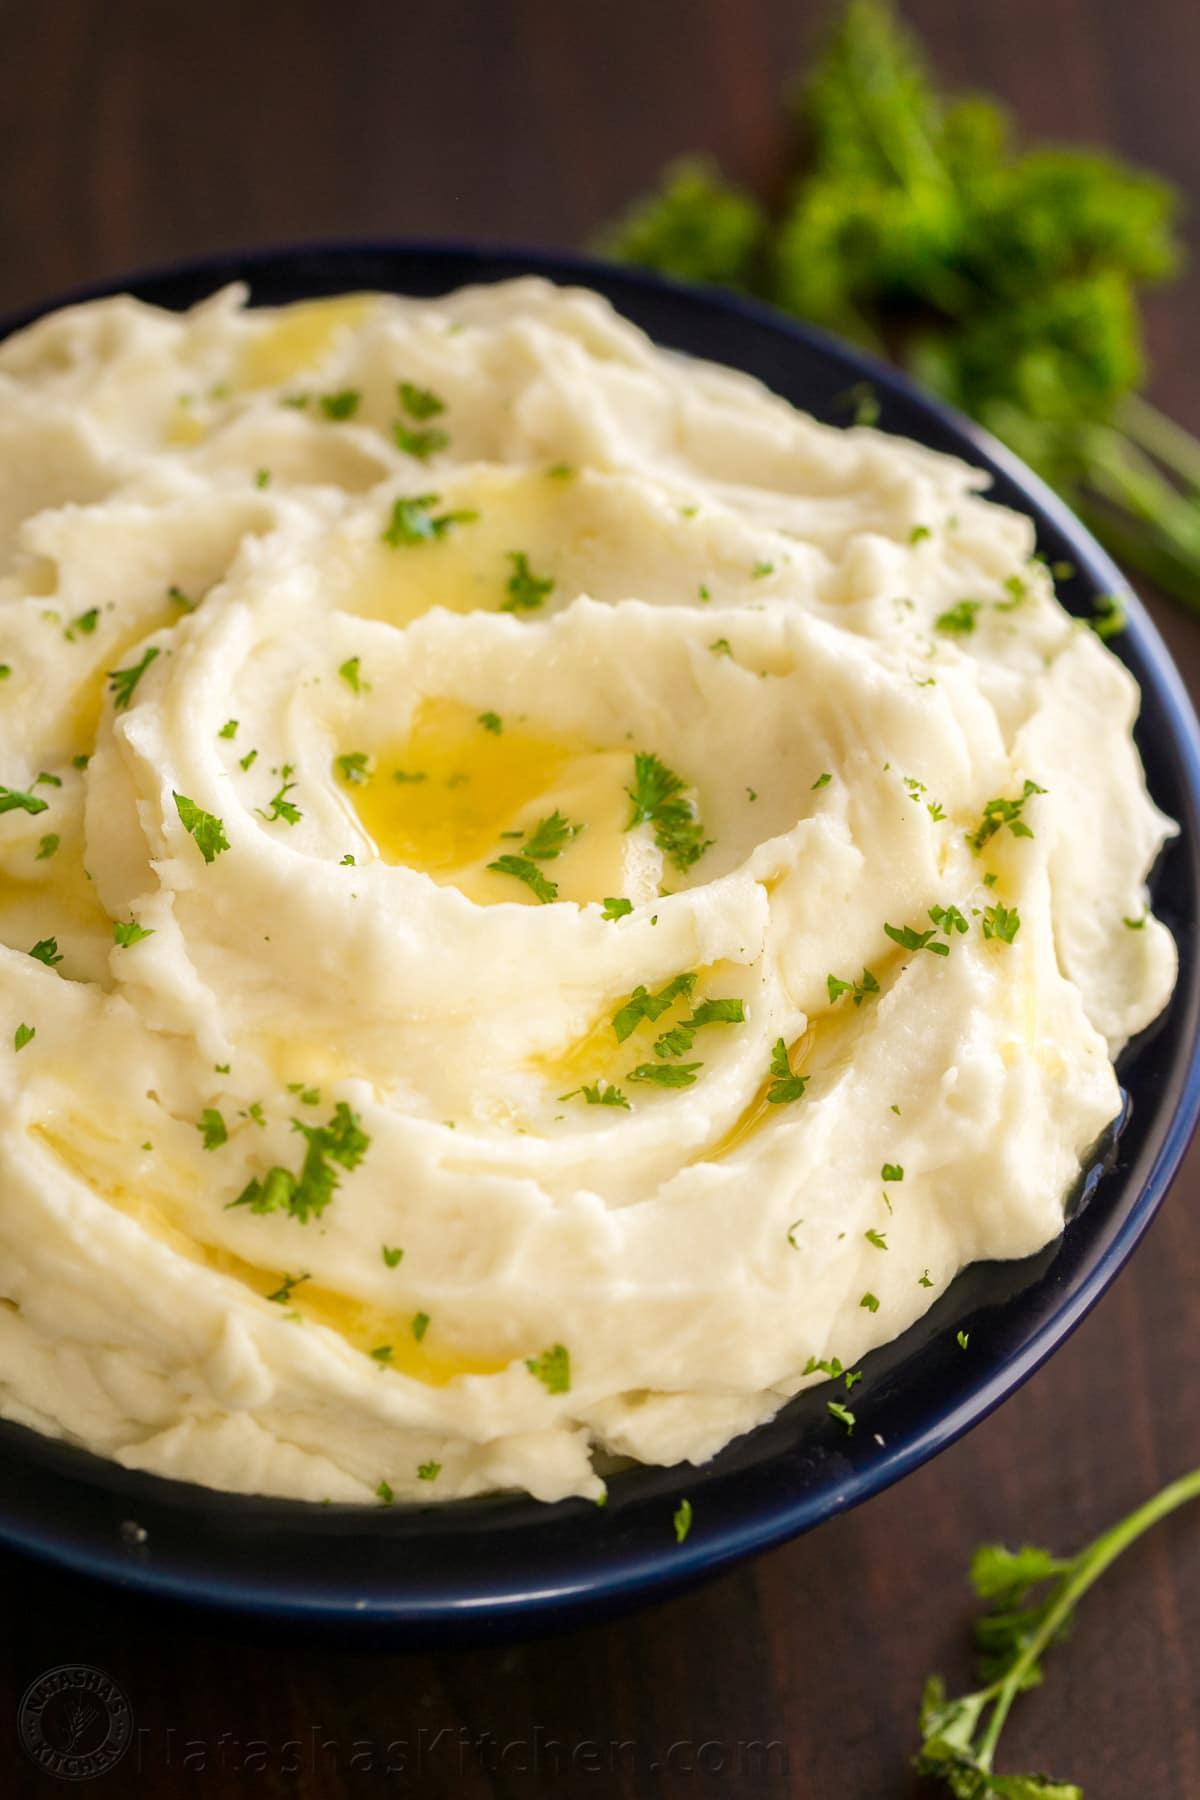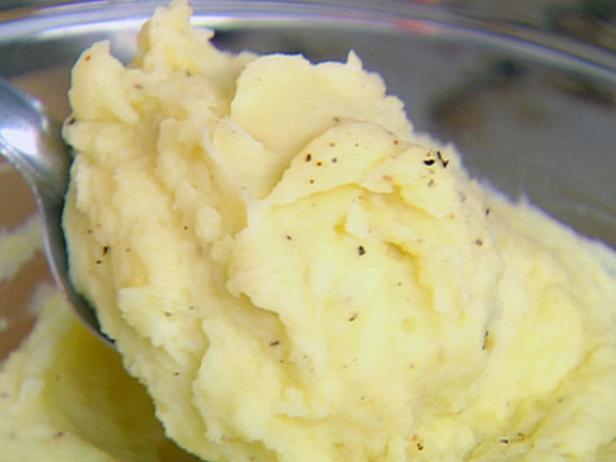The first image is the image on the left, the second image is the image on the right. Given the left and right images, does the statement "There is a spoon in the food on the right, but not on the left." hold true? Answer yes or no. Yes. 